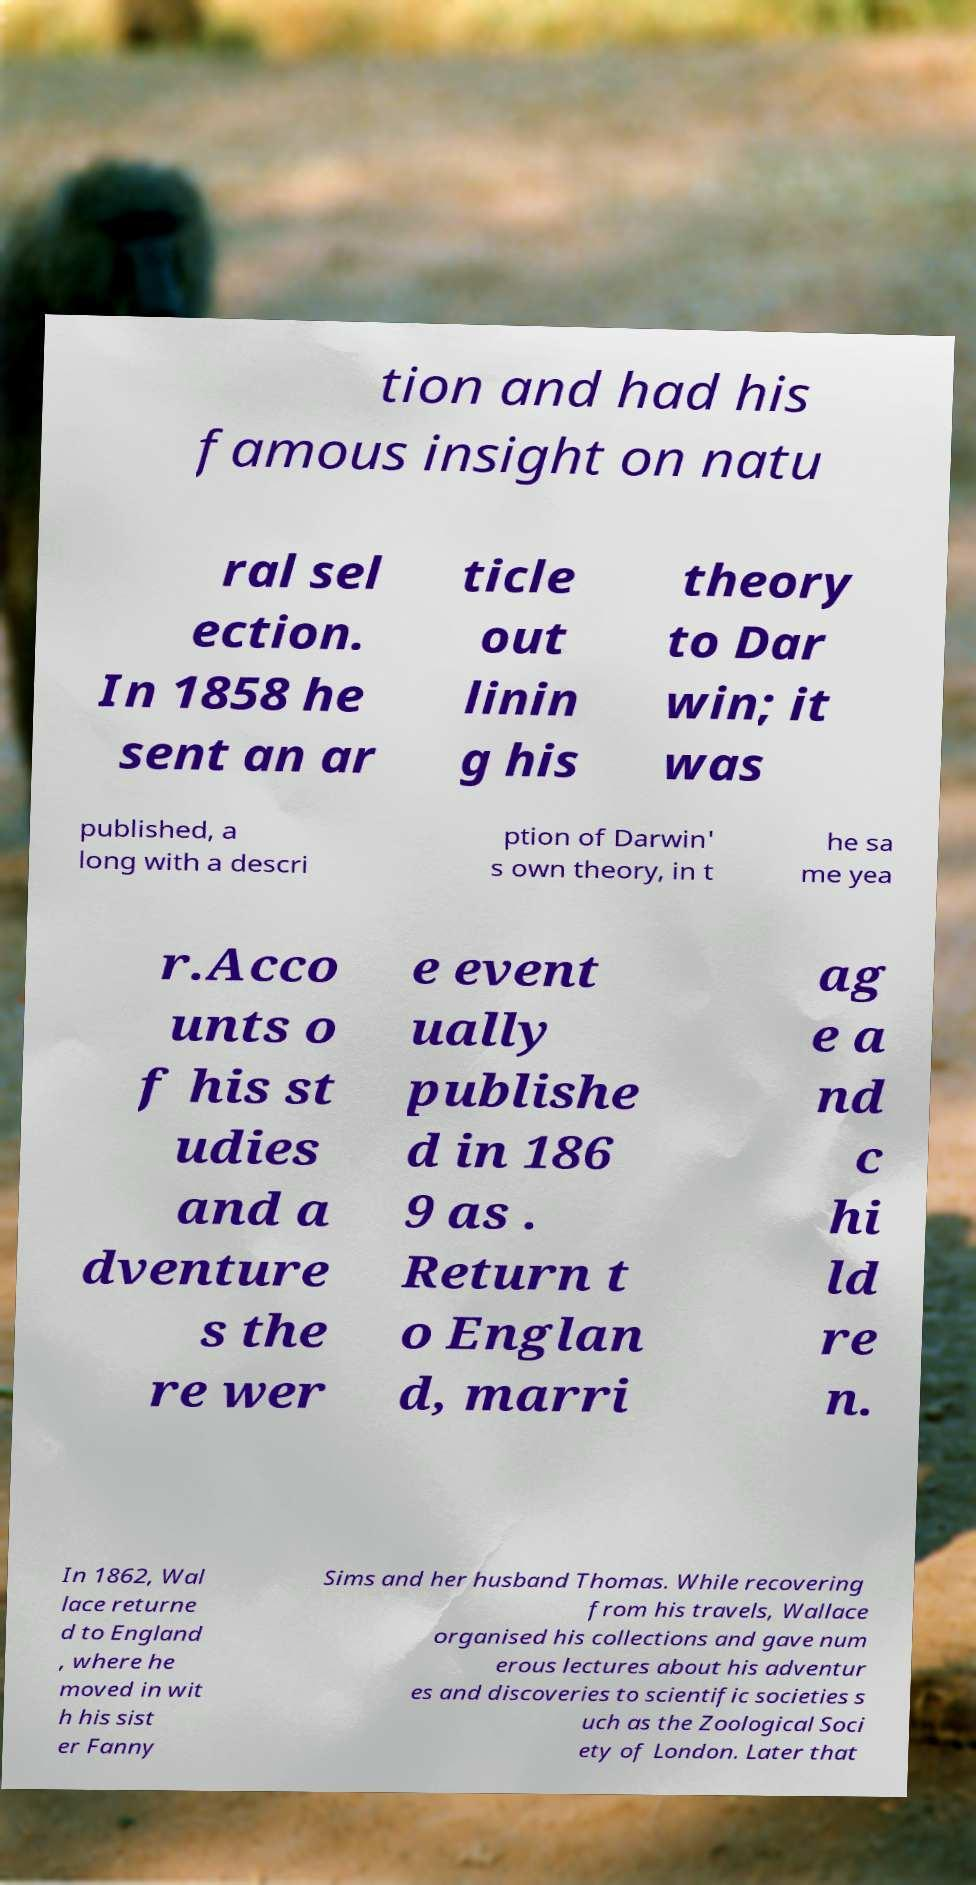Please identify and transcribe the text found in this image. tion and had his famous insight on natu ral sel ection. In 1858 he sent an ar ticle out linin g his theory to Dar win; it was published, a long with a descri ption of Darwin' s own theory, in t he sa me yea r.Acco unts o f his st udies and a dventure s the re wer e event ually publishe d in 186 9 as . Return t o Englan d, marri ag e a nd c hi ld re n. In 1862, Wal lace returne d to England , where he moved in wit h his sist er Fanny Sims and her husband Thomas. While recovering from his travels, Wallace organised his collections and gave num erous lectures about his adventur es and discoveries to scientific societies s uch as the Zoological Soci ety of London. Later that 